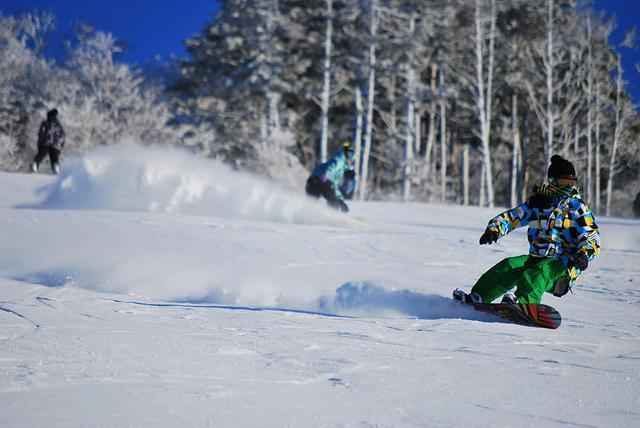How many people are seen  in the photo?
Give a very brief answer. 3. How many people are visible?
Give a very brief answer. 2. 